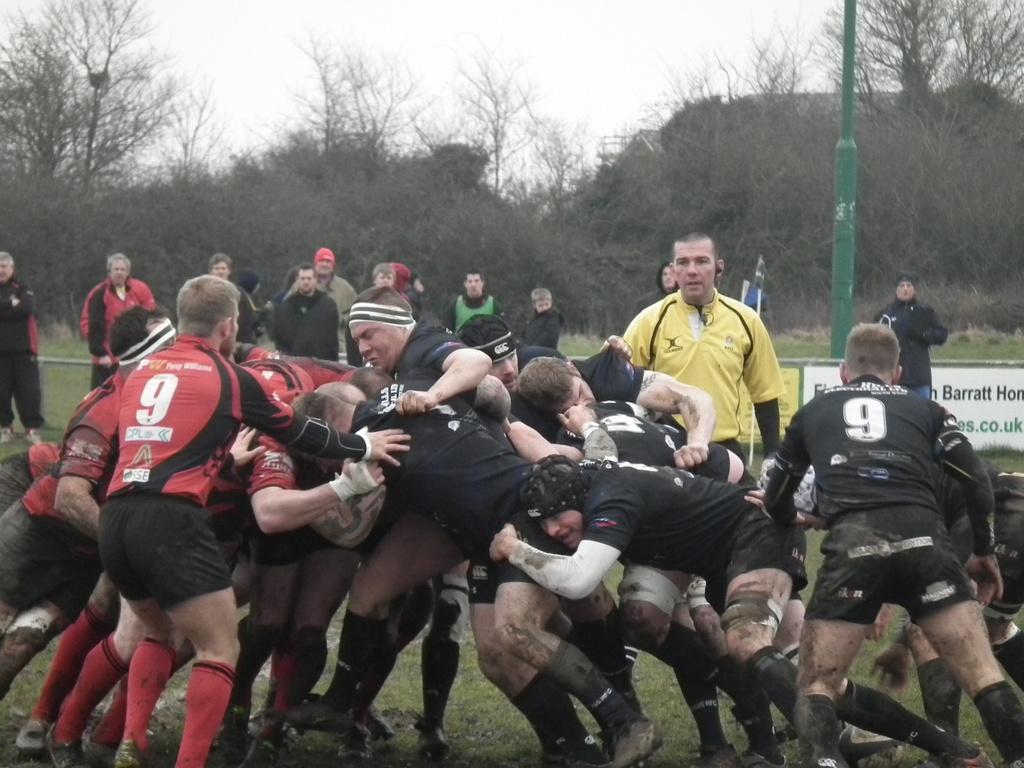Can you describe this image briefly? In this picture I can observe few people playing rugby in the middle of the picture. Most of them are men. In the background I can observe trees and sky. 